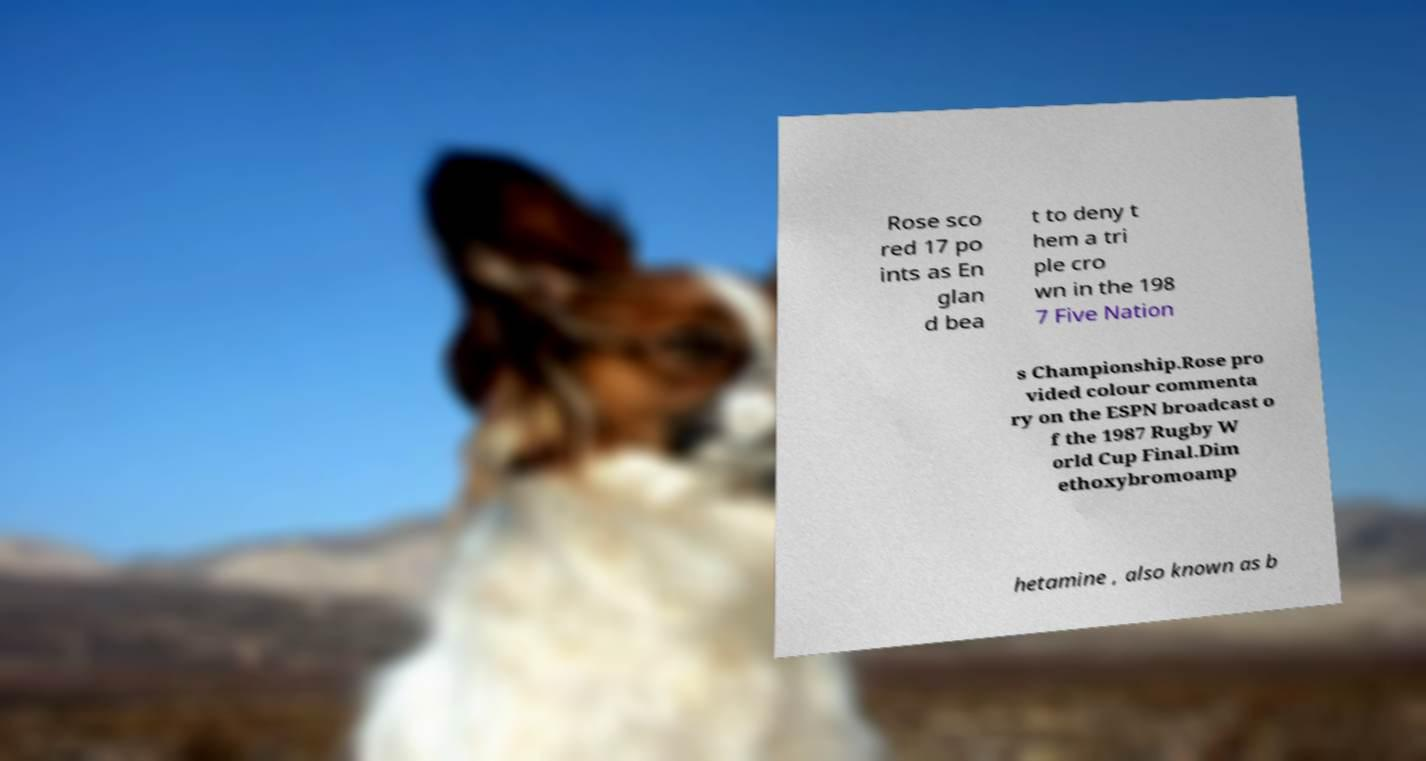I need the written content from this picture converted into text. Can you do that? Rose sco red 17 po ints as En glan d bea t to deny t hem a tri ple cro wn in the 198 7 Five Nation s Championship.Rose pro vided colour commenta ry on the ESPN broadcast o f the 1987 Rugby W orld Cup Final.Dim ethoxybromoamp hetamine , also known as b 